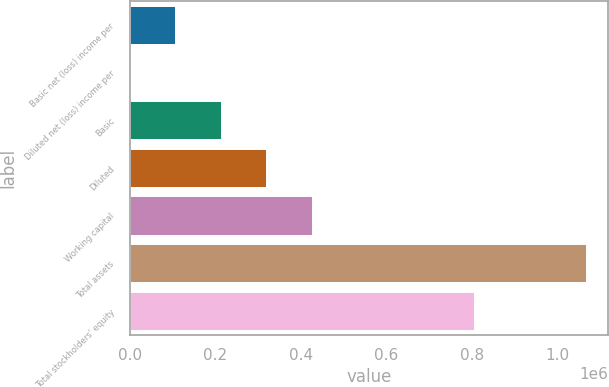Convert chart. <chart><loc_0><loc_0><loc_500><loc_500><bar_chart><fcel>Basic net (loss) income per<fcel>Diluted net (loss) income per<fcel>Basic<fcel>Diluted<fcel>Working capital<fcel>Total assets<fcel>Total stockholders' equity<nl><fcel>106636<fcel>0.86<fcel>213270<fcel>319905<fcel>426540<fcel>1.06635e+06<fcel>805723<nl></chart> 